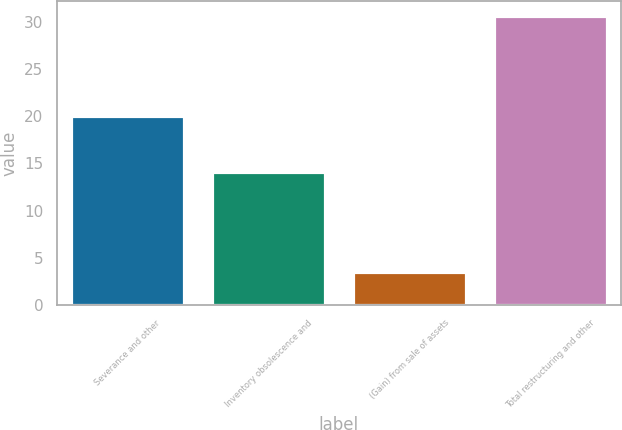Convert chart to OTSL. <chart><loc_0><loc_0><loc_500><loc_500><bar_chart><fcel>Severance and other<fcel>Inventory obsolescence and<fcel>(Gain) from sale of assets<fcel>Total restructuring and other<nl><fcel>20<fcel>14.1<fcel>3.5<fcel>30.6<nl></chart> 